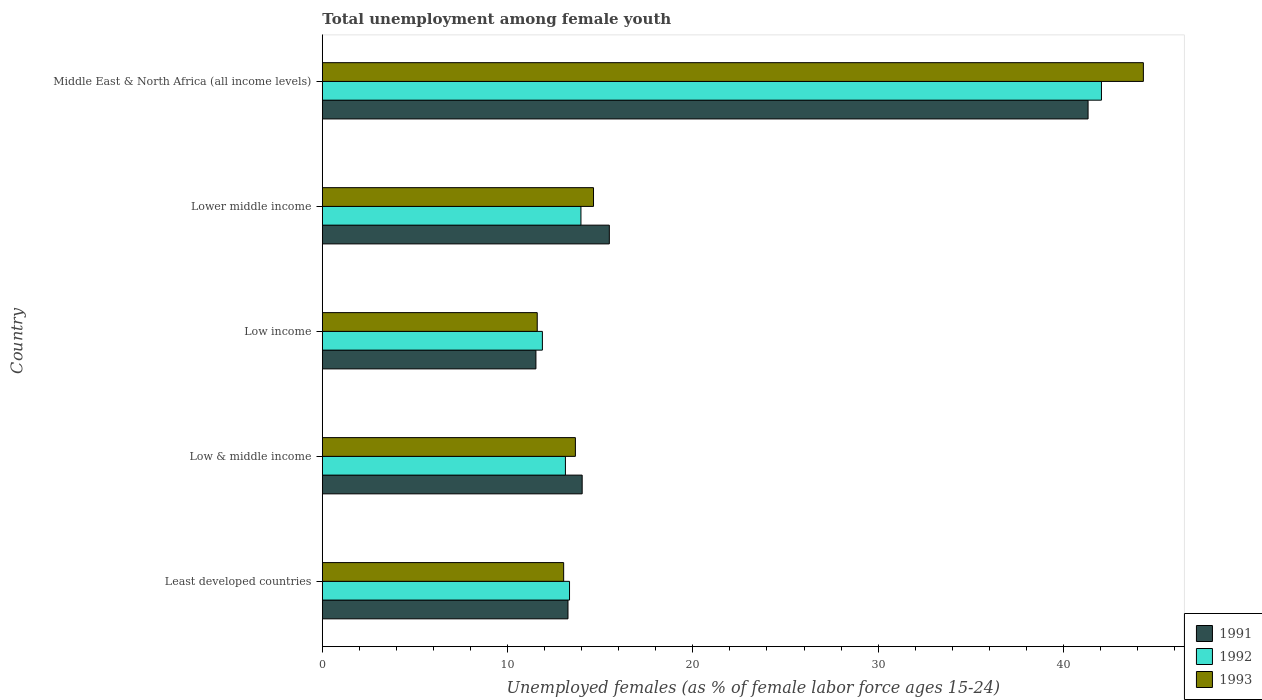How many different coloured bars are there?
Keep it short and to the point. 3. Are the number of bars on each tick of the Y-axis equal?
Your response must be concise. Yes. How many bars are there on the 2nd tick from the top?
Provide a short and direct response. 3. What is the label of the 1st group of bars from the top?
Your answer should be very brief. Middle East & North Africa (all income levels). What is the percentage of unemployed females in in 1991 in Lower middle income?
Your answer should be compact. 15.49. Across all countries, what is the maximum percentage of unemployed females in in 1993?
Make the answer very short. 44.32. Across all countries, what is the minimum percentage of unemployed females in in 1993?
Offer a terse response. 11.6. In which country was the percentage of unemployed females in in 1992 maximum?
Offer a very short reply. Middle East & North Africa (all income levels). In which country was the percentage of unemployed females in in 1991 minimum?
Keep it short and to the point. Low income. What is the total percentage of unemployed females in in 1992 in the graph?
Your response must be concise. 94.36. What is the difference between the percentage of unemployed females in in 1991 in Least developed countries and that in Lower middle income?
Your answer should be compact. -2.23. What is the difference between the percentage of unemployed females in in 1992 in Lower middle income and the percentage of unemployed females in in 1991 in Middle East & North Africa (all income levels)?
Your response must be concise. -27.37. What is the average percentage of unemployed females in in 1993 per country?
Give a very brief answer. 19.45. What is the difference between the percentage of unemployed females in in 1992 and percentage of unemployed females in in 1991 in Lower middle income?
Your answer should be very brief. -1.53. What is the ratio of the percentage of unemployed females in in 1991 in Low & middle income to that in Lower middle income?
Give a very brief answer. 0.91. Is the percentage of unemployed females in in 1991 in Least developed countries less than that in Lower middle income?
Provide a succinct answer. Yes. What is the difference between the highest and the second highest percentage of unemployed females in in 1993?
Keep it short and to the point. 29.68. What is the difference between the highest and the lowest percentage of unemployed females in in 1991?
Provide a short and direct response. 29.8. Is the sum of the percentage of unemployed females in in 1993 in Low & middle income and Middle East & North Africa (all income levels) greater than the maximum percentage of unemployed females in in 1991 across all countries?
Make the answer very short. Yes. How many bars are there?
Offer a terse response. 15. Are all the bars in the graph horizontal?
Provide a short and direct response. Yes. How many countries are there in the graph?
Give a very brief answer. 5. Are the values on the major ticks of X-axis written in scientific E-notation?
Provide a short and direct response. No. Does the graph contain any zero values?
Make the answer very short. No. Does the graph contain grids?
Ensure brevity in your answer.  No. Where does the legend appear in the graph?
Your answer should be very brief. Bottom right. How many legend labels are there?
Offer a very short reply. 3. What is the title of the graph?
Make the answer very short. Total unemployment among female youth. Does "1965" appear as one of the legend labels in the graph?
Ensure brevity in your answer.  No. What is the label or title of the X-axis?
Keep it short and to the point. Unemployed females (as % of female labor force ages 15-24). What is the label or title of the Y-axis?
Make the answer very short. Country. What is the Unemployed females (as % of female labor force ages 15-24) in 1991 in Least developed countries?
Keep it short and to the point. 13.26. What is the Unemployed females (as % of female labor force ages 15-24) in 1992 in Least developed countries?
Make the answer very short. 13.34. What is the Unemployed females (as % of female labor force ages 15-24) in 1993 in Least developed countries?
Your answer should be compact. 13.03. What is the Unemployed females (as % of female labor force ages 15-24) in 1991 in Low & middle income?
Offer a very short reply. 14.03. What is the Unemployed females (as % of female labor force ages 15-24) in 1992 in Low & middle income?
Your response must be concise. 13.12. What is the Unemployed females (as % of female labor force ages 15-24) of 1993 in Low & middle income?
Provide a succinct answer. 13.66. What is the Unemployed females (as % of female labor force ages 15-24) of 1991 in Low income?
Provide a short and direct response. 11.53. What is the Unemployed females (as % of female labor force ages 15-24) of 1992 in Low income?
Give a very brief answer. 11.88. What is the Unemployed females (as % of female labor force ages 15-24) of 1993 in Low income?
Your response must be concise. 11.6. What is the Unemployed females (as % of female labor force ages 15-24) of 1991 in Lower middle income?
Your answer should be very brief. 15.49. What is the Unemployed females (as % of female labor force ages 15-24) in 1992 in Lower middle income?
Keep it short and to the point. 13.96. What is the Unemployed females (as % of female labor force ages 15-24) of 1993 in Lower middle income?
Your answer should be very brief. 14.64. What is the Unemployed females (as % of female labor force ages 15-24) in 1991 in Middle East & North Africa (all income levels)?
Offer a very short reply. 41.33. What is the Unemployed females (as % of female labor force ages 15-24) in 1992 in Middle East & North Africa (all income levels)?
Offer a very short reply. 42.05. What is the Unemployed females (as % of female labor force ages 15-24) in 1993 in Middle East & North Africa (all income levels)?
Your answer should be compact. 44.32. Across all countries, what is the maximum Unemployed females (as % of female labor force ages 15-24) in 1991?
Your response must be concise. 41.33. Across all countries, what is the maximum Unemployed females (as % of female labor force ages 15-24) of 1992?
Keep it short and to the point. 42.05. Across all countries, what is the maximum Unemployed females (as % of female labor force ages 15-24) in 1993?
Offer a terse response. 44.32. Across all countries, what is the minimum Unemployed females (as % of female labor force ages 15-24) in 1991?
Provide a succinct answer. 11.53. Across all countries, what is the minimum Unemployed females (as % of female labor force ages 15-24) of 1992?
Your answer should be very brief. 11.88. Across all countries, what is the minimum Unemployed females (as % of female labor force ages 15-24) in 1993?
Offer a terse response. 11.6. What is the total Unemployed females (as % of female labor force ages 15-24) of 1991 in the graph?
Offer a terse response. 95.64. What is the total Unemployed females (as % of female labor force ages 15-24) of 1992 in the graph?
Your answer should be compact. 94.36. What is the total Unemployed females (as % of female labor force ages 15-24) in 1993 in the graph?
Your response must be concise. 97.24. What is the difference between the Unemployed females (as % of female labor force ages 15-24) of 1991 in Least developed countries and that in Low & middle income?
Offer a very short reply. -0.77. What is the difference between the Unemployed females (as % of female labor force ages 15-24) of 1992 in Least developed countries and that in Low & middle income?
Provide a succinct answer. 0.22. What is the difference between the Unemployed females (as % of female labor force ages 15-24) of 1993 in Least developed countries and that in Low & middle income?
Ensure brevity in your answer.  -0.63. What is the difference between the Unemployed females (as % of female labor force ages 15-24) of 1991 in Least developed countries and that in Low income?
Give a very brief answer. 1.73. What is the difference between the Unemployed females (as % of female labor force ages 15-24) of 1992 in Least developed countries and that in Low income?
Offer a very short reply. 1.47. What is the difference between the Unemployed females (as % of female labor force ages 15-24) in 1993 in Least developed countries and that in Low income?
Your answer should be compact. 1.43. What is the difference between the Unemployed females (as % of female labor force ages 15-24) of 1991 in Least developed countries and that in Lower middle income?
Make the answer very short. -2.23. What is the difference between the Unemployed females (as % of female labor force ages 15-24) in 1992 in Least developed countries and that in Lower middle income?
Make the answer very short. -0.62. What is the difference between the Unemployed females (as % of female labor force ages 15-24) in 1993 in Least developed countries and that in Lower middle income?
Provide a short and direct response. -1.61. What is the difference between the Unemployed females (as % of female labor force ages 15-24) in 1991 in Least developed countries and that in Middle East & North Africa (all income levels)?
Make the answer very short. -28.07. What is the difference between the Unemployed females (as % of female labor force ages 15-24) of 1992 in Least developed countries and that in Middle East & North Africa (all income levels)?
Your answer should be compact. -28.71. What is the difference between the Unemployed females (as % of female labor force ages 15-24) of 1993 in Least developed countries and that in Middle East & North Africa (all income levels)?
Your answer should be very brief. -31.29. What is the difference between the Unemployed females (as % of female labor force ages 15-24) of 1991 in Low & middle income and that in Low income?
Your response must be concise. 2.5. What is the difference between the Unemployed females (as % of female labor force ages 15-24) in 1992 in Low & middle income and that in Low income?
Offer a very short reply. 1.24. What is the difference between the Unemployed females (as % of female labor force ages 15-24) in 1993 in Low & middle income and that in Low income?
Provide a succinct answer. 2.06. What is the difference between the Unemployed females (as % of female labor force ages 15-24) of 1991 in Low & middle income and that in Lower middle income?
Make the answer very short. -1.47. What is the difference between the Unemployed females (as % of female labor force ages 15-24) of 1992 in Low & middle income and that in Lower middle income?
Your response must be concise. -0.84. What is the difference between the Unemployed females (as % of female labor force ages 15-24) in 1993 in Low & middle income and that in Lower middle income?
Provide a succinct answer. -0.98. What is the difference between the Unemployed females (as % of female labor force ages 15-24) of 1991 in Low & middle income and that in Middle East & North Africa (all income levels)?
Provide a succinct answer. -27.31. What is the difference between the Unemployed females (as % of female labor force ages 15-24) in 1992 in Low & middle income and that in Middle East & North Africa (all income levels)?
Your answer should be compact. -28.93. What is the difference between the Unemployed females (as % of female labor force ages 15-24) of 1993 in Low & middle income and that in Middle East & North Africa (all income levels)?
Your answer should be very brief. -30.66. What is the difference between the Unemployed females (as % of female labor force ages 15-24) of 1991 in Low income and that in Lower middle income?
Offer a very short reply. -3.96. What is the difference between the Unemployed females (as % of female labor force ages 15-24) in 1992 in Low income and that in Lower middle income?
Provide a short and direct response. -2.08. What is the difference between the Unemployed females (as % of female labor force ages 15-24) of 1993 in Low income and that in Lower middle income?
Your response must be concise. -3.04. What is the difference between the Unemployed females (as % of female labor force ages 15-24) in 1991 in Low income and that in Middle East & North Africa (all income levels)?
Offer a terse response. -29.8. What is the difference between the Unemployed females (as % of female labor force ages 15-24) of 1992 in Low income and that in Middle East & North Africa (all income levels)?
Your answer should be very brief. -30.18. What is the difference between the Unemployed females (as % of female labor force ages 15-24) in 1993 in Low income and that in Middle East & North Africa (all income levels)?
Your response must be concise. -32.72. What is the difference between the Unemployed females (as % of female labor force ages 15-24) of 1991 in Lower middle income and that in Middle East & North Africa (all income levels)?
Your response must be concise. -25.84. What is the difference between the Unemployed females (as % of female labor force ages 15-24) in 1992 in Lower middle income and that in Middle East & North Africa (all income levels)?
Make the answer very short. -28.1. What is the difference between the Unemployed females (as % of female labor force ages 15-24) in 1993 in Lower middle income and that in Middle East & North Africa (all income levels)?
Offer a very short reply. -29.68. What is the difference between the Unemployed females (as % of female labor force ages 15-24) in 1991 in Least developed countries and the Unemployed females (as % of female labor force ages 15-24) in 1992 in Low & middle income?
Provide a succinct answer. 0.14. What is the difference between the Unemployed females (as % of female labor force ages 15-24) of 1991 in Least developed countries and the Unemployed females (as % of female labor force ages 15-24) of 1993 in Low & middle income?
Make the answer very short. -0.4. What is the difference between the Unemployed females (as % of female labor force ages 15-24) in 1992 in Least developed countries and the Unemployed females (as % of female labor force ages 15-24) in 1993 in Low & middle income?
Make the answer very short. -0.32. What is the difference between the Unemployed females (as % of female labor force ages 15-24) in 1991 in Least developed countries and the Unemployed females (as % of female labor force ages 15-24) in 1992 in Low income?
Your response must be concise. 1.38. What is the difference between the Unemployed females (as % of female labor force ages 15-24) in 1991 in Least developed countries and the Unemployed females (as % of female labor force ages 15-24) in 1993 in Low income?
Make the answer very short. 1.66. What is the difference between the Unemployed females (as % of female labor force ages 15-24) in 1992 in Least developed countries and the Unemployed females (as % of female labor force ages 15-24) in 1993 in Low income?
Your answer should be very brief. 1.74. What is the difference between the Unemployed females (as % of female labor force ages 15-24) of 1991 in Least developed countries and the Unemployed females (as % of female labor force ages 15-24) of 1992 in Lower middle income?
Your answer should be compact. -0.7. What is the difference between the Unemployed females (as % of female labor force ages 15-24) of 1991 in Least developed countries and the Unemployed females (as % of female labor force ages 15-24) of 1993 in Lower middle income?
Ensure brevity in your answer.  -1.38. What is the difference between the Unemployed females (as % of female labor force ages 15-24) in 1992 in Least developed countries and the Unemployed females (as % of female labor force ages 15-24) in 1993 in Lower middle income?
Your response must be concise. -1.29. What is the difference between the Unemployed females (as % of female labor force ages 15-24) in 1991 in Least developed countries and the Unemployed females (as % of female labor force ages 15-24) in 1992 in Middle East & North Africa (all income levels)?
Your answer should be compact. -28.79. What is the difference between the Unemployed females (as % of female labor force ages 15-24) of 1991 in Least developed countries and the Unemployed females (as % of female labor force ages 15-24) of 1993 in Middle East & North Africa (all income levels)?
Ensure brevity in your answer.  -31.06. What is the difference between the Unemployed females (as % of female labor force ages 15-24) in 1992 in Least developed countries and the Unemployed females (as % of female labor force ages 15-24) in 1993 in Middle East & North Africa (all income levels)?
Your answer should be very brief. -30.97. What is the difference between the Unemployed females (as % of female labor force ages 15-24) in 1991 in Low & middle income and the Unemployed females (as % of female labor force ages 15-24) in 1992 in Low income?
Offer a terse response. 2.15. What is the difference between the Unemployed females (as % of female labor force ages 15-24) in 1991 in Low & middle income and the Unemployed females (as % of female labor force ages 15-24) in 1993 in Low income?
Your answer should be compact. 2.43. What is the difference between the Unemployed females (as % of female labor force ages 15-24) in 1992 in Low & middle income and the Unemployed females (as % of female labor force ages 15-24) in 1993 in Low income?
Provide a succinct answer. 1.52. What is the difference between the Unemployed females (as % of female labor force ages 15-24) in 1991 in Low & middle income and the Unemployed females (as % of female labor force ages 15-24) in 1992 in Lower middle income?
Your answer should be compact. 0.07. What is the difference between the Unemployed females (as % of female labor force ages 15-24) in 1991 in Low & middle income and the Unemployed females (as % of female labor force ages 15-24) in 1993 in Lower middle income?
Offer a very short reply. -0.61. What is the difference between the Unemployed females (as % of female labor force ages 15-24) in 1992 in Low & middle income and the Unemployed females (as % of female labor force ages 15-24) in 1993 in Lower middle income?
Your answer should be compact. -1.52. What is the difference between the Unemployed females (as % of female labor force ages 15-24) in 1991 in Low & middle income and the Unemployed females (as % of female labor force ages 15-24) in 1992 in Middle East & North Africa (all income levels)?
Offer a terse response. -28.03. What is the difference between the Unemployed females (as % of female labor force ages 15-24) in 1991 in Low & middle income and the Unemployed females (as % of female labor force ages 15-24) in 1993 in Middle East & North Africa (all income levels)?
Your answer should be very brief. -30.29. What is the difference between the Unemployed females (as % of female labor force ages 15-24) in 1992 in Low & middle income and the Unemployed females (as % of female labor force ages 15-24) in 1993 in Middle East & North Africa (all income levels)?
Offer a very short reply. -31.2. What is the difference between the Unemployed females (as % of female labor force ages 15-24) in 1991 in Low income and the Unemployed females (as % of female labor force ages 15-24) in 1992 in Lower middle income?
Your answer should be compact. -2.43. What is the difference between the Unemployed females (as % of female labor force ages 15-24) of 1991 in Low income and the Unemployed females (as % of female labor force ages 15-24) of 1993 in Lower middle income?
Offer a very short reply. -3.11. What is the difference between the Unemployed females (as % of female labor force ages 15-24) in 1992 in Low income and the Unemployed females (as % of female labor force ages 15-24) in 1993 in Lower middle income?
Give a very brief answer. -2.76. What is the difference between the Unemployed females (as % of female labor force ages 15-24) in 1991 in Low income and the Unemployed females (as % of female labor force ages 15-24) in 1992 in Middle East & North Africa (all income levels)?
Ensure brevity in your answer.  -30.52. What is the difference between the Unemployed females (as % of female labor force ages 15-24) of 1991 in Low income and the Unemployed females (as % of female labor force ages 15-24) of 1993 in Middle East & North Africa (all income levels)?
Offer a very short reply. -32.79. What is the difference between the Unemployed females (as % of female labor force ages 15-24) in 1992 in Low income and the Unemployed females (as % of female labor force ages 15-24) in 1993 in Middle East & North Africa (all income levels)?
Provide a succinct answer. -32.44. What is the difference between the Unemployed females (as % of female labor force ages 15-24) in 1991 in Lower middle income and the Unemployed females (as % of female labor force ages 15-24) in 1992 in Middle East & North Africa (all income levels)?
Ensure brevity in your answer.  -26.56. What is the difference between the Unemployed females (as % of female labor force ages 15-24) in 1991 in Lower middle income and the Unemployed females (as % of female labor force ages 15-24) in 1993 in Middle East & North Africa (all income levels)?
Make the answer very short. -28.83. What is the difference between the Unemployed females (as % of female labor force ages 15-24) of 1992 in Lower middle income and the Unemployed females (as % of female labor force ages 15-24) of 1993 in Middle East & North Africa (all income levels)?
Ensure brevity in your answer.  -30.36. What is the average Unemployed females (as % of female labor force ages 15-24) of 1991 per country?
Give a very brief answer. 19.13. What is the average Unemployed females (as % of female labor force ages 15-24) in 1992 per country?
Your response must be concise. 18.87. What is the average Unemployed females (as % of female labor force ages 15-24) in 1993 per country?
Make the answer very short. 19.45. What is the difference between the Unemployed females (as % of female labor force ages 15-24) in 1991 and Unemployed females (as % of female labor force ages 15-24) in 1992 in Least developed countries?
Offer a terse response. -0.08. What is the difference between the Unemployed females (as % of female labor force ages 15-24) of 1991 and Unemployed females (as % of female labor force ages 15-24) of 1993 in Least developed countries?
Give a very brief answer. 0.23. What is the difference between the Unemployed females (as % of female labor force ages 15-24) of 1992 and Unemployed females (as % of female labor force ages 15-24) of 1993 in Least developed countries?
Ensure brevity in your answer.  0.32. What is the difference between the Unemployed females (as % of female labor force ages 15-24) in 1991 and Unemployed females (as % of female labor force ages 15-24) in 1992 in Low & middle income?
Provide a short and direct response. 0.9. What is the difference between the Unemployed females (as % of female labor force ages 15-24) in 1991 and Unemployed females (as % of female labor force ages 15-24) in 1993 in Low & middle income?
Ensure brevity in your answer.  0.37. What is the difference between the Unemployed females (as % of female labor force ages 15-24) of 1992 and Unemployed females (as % of female labor force ages 15-24) of 1993 in Low & middle income?
Your answer should be very brief. -0.54. What is the difference between the Unemployed females (as % of female labor force ages 15-24) of 1991 and Unemployed females (as % of female labor force ages 15-24) of 1992 in Low income?
Ensure brevity in your answer.  -0.35. What is the difference between the Unemployed females (as % of female labor force ages 15-24) in 1991 and Unemployed females (as % of female labor force ages 15-24) in 1993 in Low income?
Give a very brief answer. -0.07. What is the difference between the Unemployed females (as % of female labor force ages 15-24) of 1992 and Unemployed females (as % of female labor force ages 15-24) of 1993 in Low income?
Your response must be concise. 0.28. What is the difference between the Unemployed females (as % of female labor force ages 15-24) of 1991 and Unemployed females (as % of female labor force ages 15-24) of 1992 in Lower middle income?
Ensure brevity in your answer.  1.53. What is the difference between the Unemployed females (as % of female labor force ages 15-24) in 1991 and Unemployed females (as % of female labor force ages 15-24) in 1993 in Lower middle income?
Offer a terse response. 0.85. What is the difference between the Unemployed females (as % of female labor force ages 15-24) of 1992 and Unemployed females (as % of female labor force ages 15-24) of 1993 in Lower middle income?
Make the answer very short. -0.68. What is the difference between the Unemployed females (as % of female labor force ages 15-24) in 1991 and Unemployed females (as % of female labor force ages 15-24) in 1992 in Middle East & North Africa (all income levels)?
Provide a short and direct response. -0.72. What is the difference between the Unemployed females (as % of female labor force ages 15-24) of 1991 and Unemployed females (as % of female labor force ages 15-24) of 1993 in Middle East & North Africa (all income levels)?
Your response must be concise. -2.99. What is the difference between the Unemployed females (as % of female labor force ages 15-24) in 1992 and Unemployed females (as % of female labor force ages 15-24) in 1993 in Middle East & North Africa (all income levels)?
Give a very brief answer. -2.26. What is the ratio of the Unemployed females (as % of female labor force ages 15-24) of 1991 in Least developed countries to that in Low & middle income?
Your answer should be compact. 0.95. What is the ratio of the Unemployed females (as % of female labor force ages 15-24) of 1992 in Least developed countries to that in Low & middle income?
Provide a succinct answer. 1.02. What is the ratio of the Unemployed females (as % of female labor force ages 15-24) of 1993 in Least developed countries to that in Low & middle income?
Make the answer very short. 0.95. What is the ratio of the Unemployed females (as % of female labor force ages 15-24) of 1991 in Least developed countries to that in Low income?
Your response must be concise. 1.15. What is the ratio of the Unemployed females (as % of female labor force ages 15-24) of 1992 in Least developed countries to that in Low income?
Give a very brief answer. 1.12. What is the ratio of the Unemployed females (as % of female labor force ages 15-24) of 1993 in Least developed countries to that in Low income?
Your answer should be compact. 1.12. What is the ratio of the Unemployed females (as % of female labor force ages 15-24) of 1991 in Least developed countries to that in Lower middle income?
Keep it short and to the point. 0.86. What is the ratio of the Unemployed females (as % of female labor force ages 15-24) of 1992 in Least developed countries to that in Lower middle income?
Your answer should be compact. 0.96. What is the ratio of the Unemployed females (as % of female labor force ages 15-24) in 1993 in Least developed countries to that in Lower middle income?
Offer a very short reply. 0.89. What is the ratio of the Unemployed females (as % of female labor force ages 15-24) in 1991 in Least developed countries to that in Middle East & North Africa (all income levels)?
Offer a very short reply. 0.32. What is the ratio of the Unemployed females (as % of female labor force ages 15-24) of 1992 in Least developed countries to that in Middle East & North Africa (all income levels)?
Make the answer very short. 0.32. What is the ratio of the Unemployed females (as % of female labor force ages 15-24) of 1993 in Least developed countries to that in Middle East & North Africa (all income levels)?
Your response must be concise. 0.29. What is the ratio of the Unemployed females (as % of female labor force ages 15-24) of 1991 in Low & middle income to that in Low income?
Offer a very short reply. 1.22. What is the ratio of the Unemployed females (as % of female labor force ages 15-24) in 1992 in Low & middle income to that in Low income?
Your response must be concise. 1.1. What is the ratio of the Unemployed females (as % of female labor force ages 15-24) of 1993 in Low & middle income to that in Low income?
Your answer should be compact. 1.18. What is the ratio of the Unemployed females (as % of female labor force ages 15-24) in 1991 in Low & middle income to that in Lower middle income?
Offer a terse response. 0.91. What is the ratio of the Unemployed females (as % of female labor force ages 15-24) in 1993 in Low & middle income to that in Lower middle income?
Offer a very short reply. 0.93. What is the ratio of the Unemployed females (as % of female labor force ages 15-24) in 1991 in Low & middle income to that in Middle East & North Africa (all income levels)?
Keep it short and to the point. 0.34. What is the ratio of the Unemployed females (as % of female labor force ages 15-24) in 1992 in Low & middle income to that in Middle East & North Africa (all income levels)?
Offer a terse response. 0.31. What is the ratio of the Unemployed females (as % of female labor force ages 15-24) of 1993 in Low & middle income to that in Middle East & North Africa (all income levels)?
Make the answer very short. 0.31. What is the ratio of the Unemployed females (as % of female labor force ages 15-24) in 1991 in Low income to that in Lower middle income?
Give a very brief answer. 0.74. What is the ratio of the Unemployed females (as % of female labor force ages 15-24) in 1992 in Low income to that in Lower middle income?
Give a very brief answer. 0.85. What is the ratio of the Unemployed females (as % of female labor force ages 15-24) of 1993 in Low income to that in Lower middle income?
Your answer should be very brief. 0.79. What is the ratio of the Unemployed females (as % of female labor force ages 15-24) in 1991 in Low income to that in Middle East & North Africa (all income levels)?
Your answer should be compact. 0.28. What is the ratio of the Unemployed females (as % of female labor force ages 15-24) of 1992 in Low income to that in Middle East & North Africa (all income levels)?
Your answer should be very brief. 0.28. What is the ratio of the Unemployed females (as % of female labor force ages 15-24) of 1993 in Low income to that in Middle East & North Africa (all income levels)?
Offer a very short reply. 0.26. What is the ratio of the Unemployed females (as % of female labor force ages 15-24) in 1991 in Lower middle income to that in Middle East & North Africa (all income levels)?
Ensure brevity in your answer.  0.37. What is the ratio of the Unemployed females (as % of female labor force ages 15-24) in 1992 in Lower middle income to that in Middle East & North Africa (all income levels)?
Give a very brief answer. 0.33. What is the ratio of the Unemployed females (as % of female labor force ages 15-24) in 1993 in Lower middle income to that in Middle East & North Africa (all income levels)?
Provide a short and direct response. 0.33. What is the difference between the highest and the second highest Unemployed females (as % of female labor force ages 15-24) in 1991?
Offer a terse response. 25.84. What is the difference between the highest and the second highest Unemployed females (as % of female labor force ages 15-24) in 1992?
Offer a very short reply. 28.1. What is the difference between the highest and the second highest Unemployed females (as % of female labor force ages 15-24) in 1993?
Ensure brevity in your answer.  29.68. What is the difference between the highest and the lowest Unemployed females (as % of female labor force ages 15-24) of 1991?
Offer a terse response. 29.8. What is the difference between the highest and the lowest Unemployed females (as % of female labor force ages 15-24) in 1992?
Your answer should be compact. 30.18. What is the difference between the highest and the lowest Unemployed females (as % of female labor force ages 15-24) of 1993?
Provide a succinct answer. 32.72. 